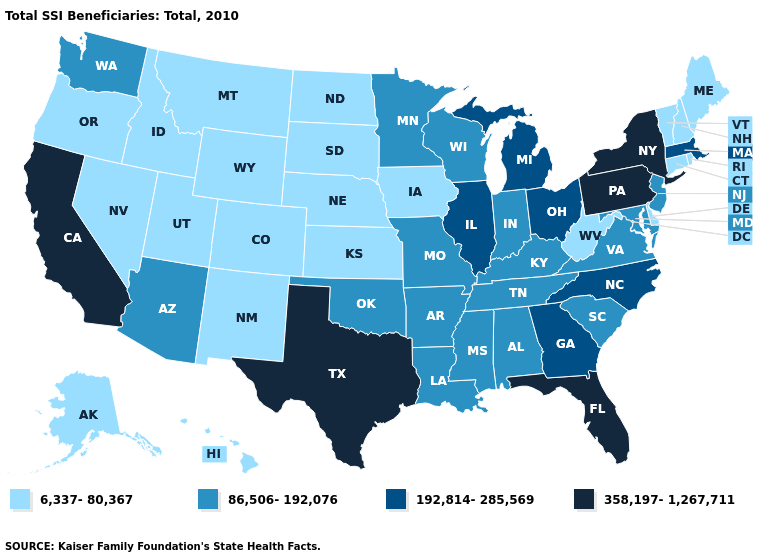What is the lowest value in the Northeast?
Give a very brief answer. 6,337-80,367. Does Indiana have the highest value in the USA?
Quick response, please. No. Among the states that border Arizona , which have the highest value?
Give a very brief answer. California. What is the highest value in states that border Kansas?
Quick response, please. 86,506-192,076. What is the value of Massachusetts?
Keep it brief. 192,814-285,569. Among the states that border Rhode Island , which have the lowest value?
Keep it brief. Connecticut. Among the states that border Washington , which have the lowest value?
Short answer required. Idaho, Oregon. What is the value of Massachusetts?
Keep it brief. 192,814-285,569. What is the value of New Jersey?
Keep it brief. 86,506-192,076. Does Washington have the lowest value in the West?
Quick response, please. No. What is the value of Oklahoma?
Concise answer only. 86,506-192,076. How many symbols are there in the legend?
Write a very short answer. 4. Which states have the lowest value in the Northeast?
Be succinct. Connecticut, Maine, New Hampshire, Rhode Island, Vermont. What is the value of Tennessee?
Quick response, please. 86,506-192,076. Among the states that border California , does Oregon have the lowest value?
Give a very brief answer. Yes. 